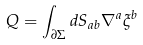<formula> <loc_0><loc_0><loc_500><loc_500>Q = \int _ { \partial \Sigma } d S _ { a b } \nabla ^ { a } \xi ^ { b }</formula> 